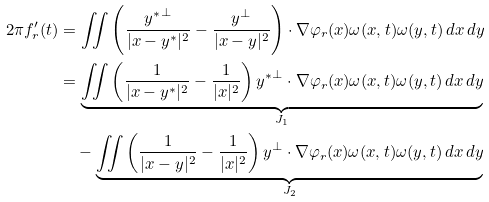<formula> <loc_0><loc_0><loc_500><loc_500>2 \pi f ^ { \prime } _ { r } ( t ) & = \iint \left ( \frac { { y ^ { \ast } } ^ { \perp } } { | x - { y ^ { \ast } } | ^ { 2 } } - \frac { y ^ { \perp } } { | x - y | ^ { 2 } } \right ) \cdot \nabla \varphi _ { r } ( x ) \omega ( x , t ) \omega ( y , t ) \, d x \, d y \\ & = \underset { J _ { 1 } } { \underbrace { \iint \left ( \frac { 1 } { | x - { y ^ { \ast } } | ^ { 2 } } - \frac { 1 } { | x | ^ { 2 } } \right ) { y ^ { \ast } } ^ { \perp } \cdot \nabla \varphi _ { r } ( x ) \omega ( x , t ) \omega ( y , t ) \, d x \, d y } } \\ & \quad - \underset { J _ { 2 } } { \underbrace { \iint \left ( \frac { 1 } { | x - y | ^ { 2 } } - \frac { 1 } { | x | ^ { 2 } } \right ) y ^ { \perp } \cdot \nabla \varphi _ { r } ( x ) \omega ( x , t ) \omega ( y , t ) \, d x \, d y } }</formula> 